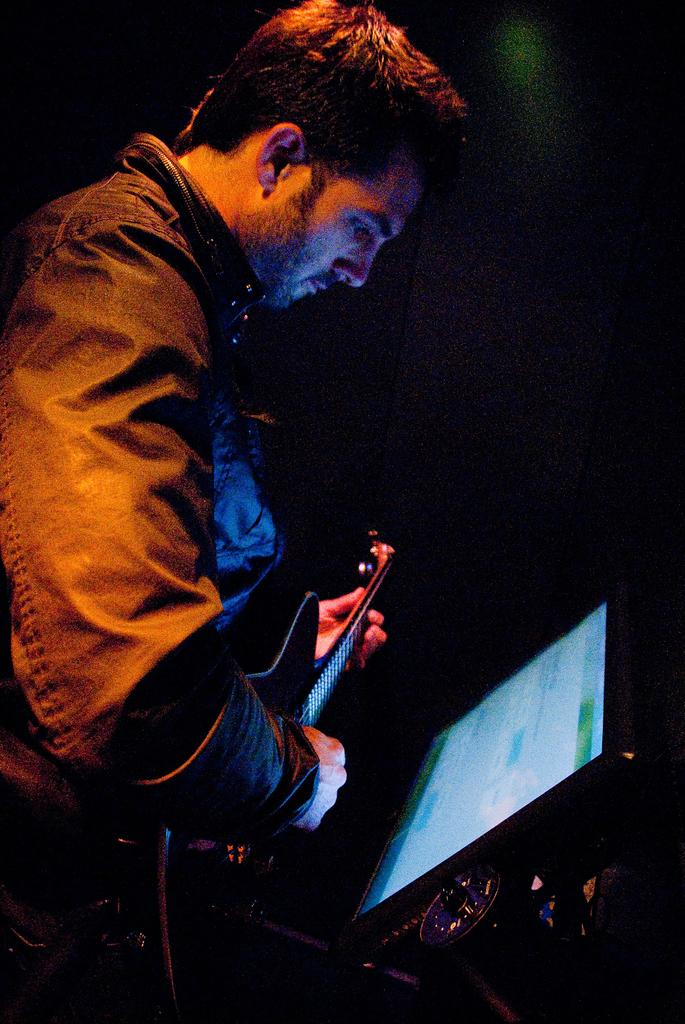What is the person in the image doing? The person is playing a guitar. What object is in front of the person? There is a screen in front of the person. What type of underwear is the person wearing in the image? There is no information about the person's underwear in the image, so it cannot be determined. 